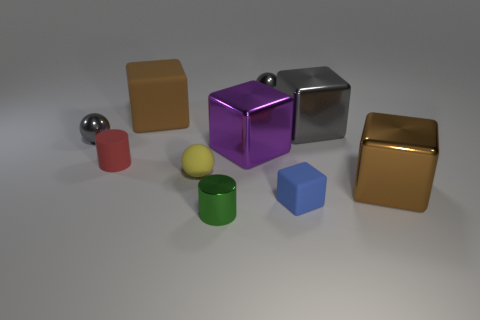There is another large cube that is the same color as the big matte block; what is it made of?
Give a very brief answer. Metal. There is a brown block behind the small gray metallic thing left of the red cylinder; what is it made of?
Ensure brevity in your answer.  Rubber. Do the blue rubber block and the green metal thing have the same size?
Give a very brief answer. Yes. What number of objects are either small gray metal balls that are to the left of the large matte thing or tiny blue objects right of the brown matte cube?
Your answer should be very brief. 2. Are there more red objects that are behind the tiny cube than tiny blue balls?
Your answer should be very brief. Yes. How many other things are there of the same shape as the purple metallic thing?
Offer a terse response. 4. What is the big thing that is behind the purple metallic cube and to the left of the small blue object made of?
Your answer should be very brief. Rubber. What number of objects are green metallic blocks or small red cylinders?
Provide a succinct answer. 1. Are there more purple shiny balls than large brown blocks?
Your answer should be very brief. No. There is a matte cube that is behind the shiny cube that is to the left of the blue object; how big is it?
Make the answer very short. Large. 